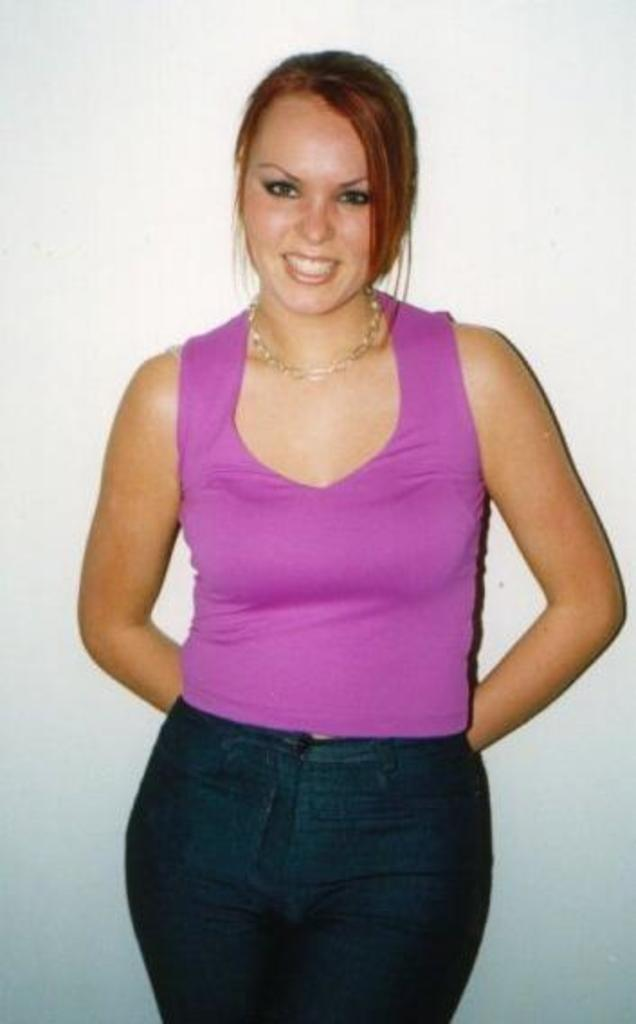Who is the main subject in the image? There is a woman in the image. What is the woman wearing on her upper body? The woman is wearing a purple top. What type of bottom wear is the woman wearing? The woman is wearing a trouser. What is the woman's facial expression in the image? The woman is smiling. What is the woman doing in the image? The woman is posing for a photograph. What can be seen behind the woman in the image? There is a wall behind the woman. What type of writer is the woman holding in the image? There is no writer present in the image; it only features a woman posing for a photograph. How many roses can be seen in the woman's hand in the image? There are no roses visible in the woman's hand in the image. 